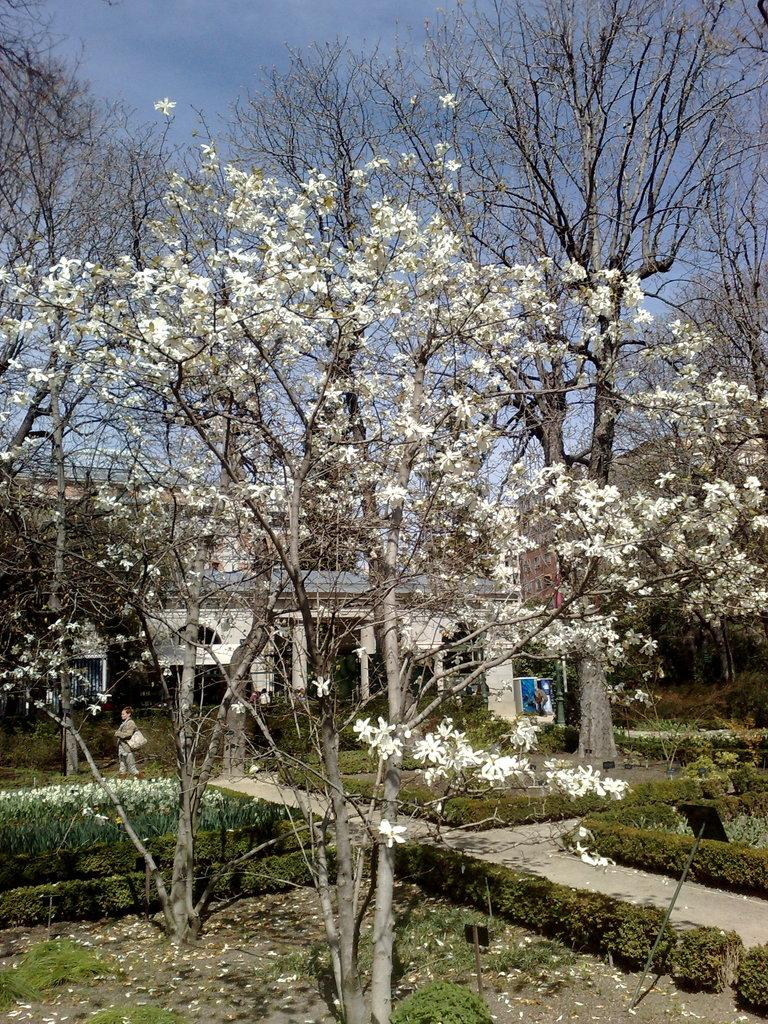What type of plant is in the image? There is a white color flower plant in the image. What can be seen behind the flower plant? There are dry trees and a small house behind the flower plant. What is visible at the bottom front side of the image? There is a ground with small plants in the front bottom side of the image. What type of chalk is being used to draw on the chair in the image? There is no chalk or chair present in the image. Can you describe the beetle crawling on the small plants in the image? There is no beetle present in the image; it only features a white color flower plant, dry trees, a small house, and small plants on the ground. 